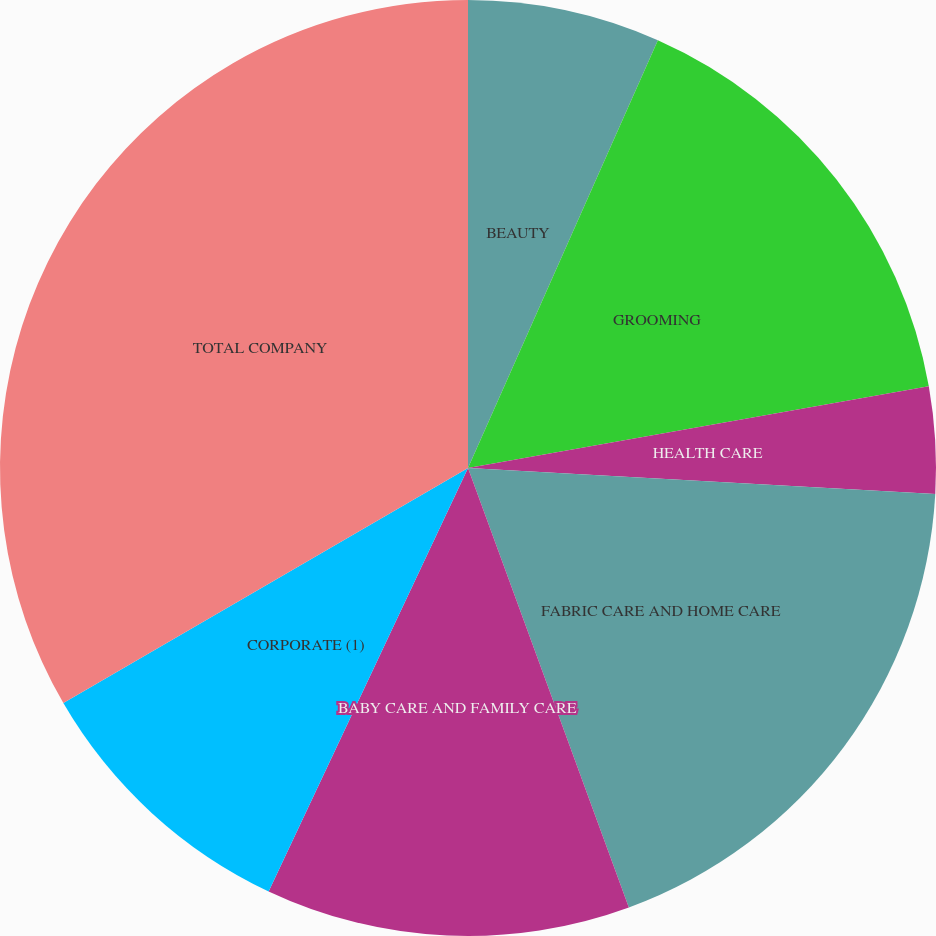Convert chart to OTSL. <chart><loc_0><loc_0><loc_500><loc_500><pie_chart><fcel>BEAUTY<fcel>GROOMING<fcel>HEALTH CARE<fcel>FABRIC CARE AND HOME CARE<fcel>BABY CARE AND FAMILY CARE<fcel>CORPORATE (1)<fcel>TOTAL COMPANY<nl><fcel>6.65%<fcel>15.56%<fcel>3.68%<fcel>18.53%<fcel>12.59%<fcel>9.62%<fcel>33.38%<nl></chart> 